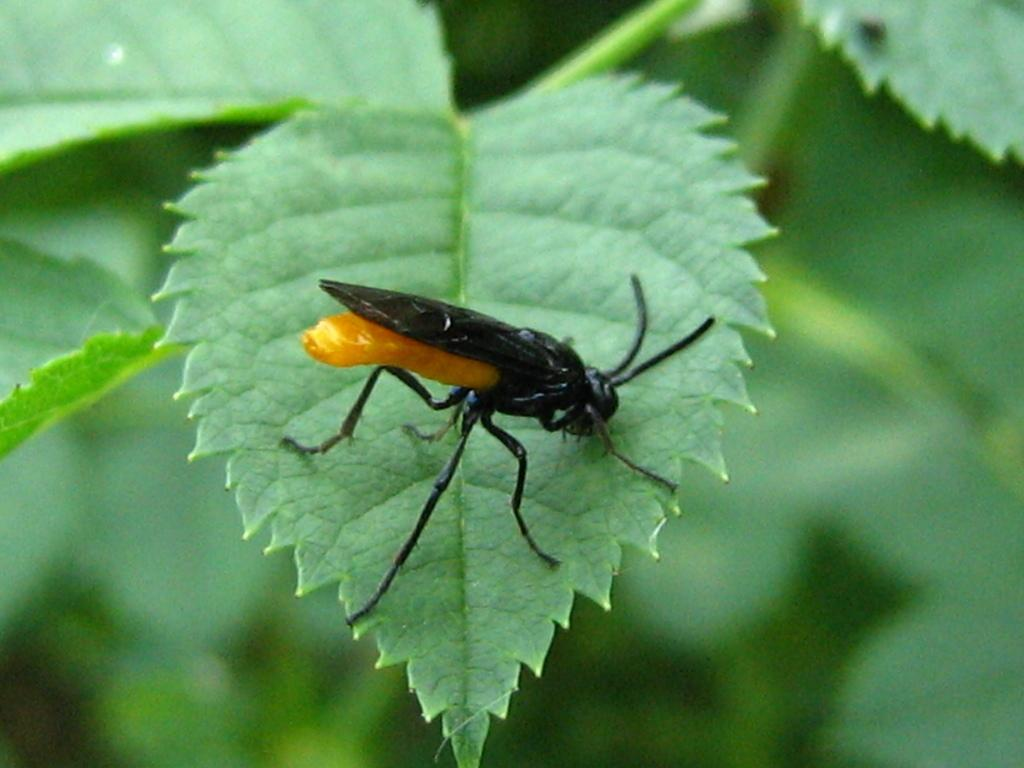What is the main subject in the center of the image? There is a fly on a leaf in the center of the image. Can you describe the positioning of the fly and leaf in the image? The fly and leaf are in the center of the image. What type of chin is visible on the fly in the image? Flies do not have chins, so there is no chin visible on the fly in the image. Is there an argument taking place between the fly and the leaf in the image? There is no indication of an argument between the fly and the leaf in the image. 